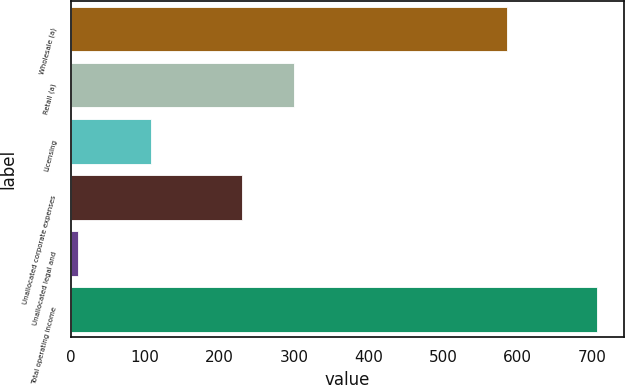<chart> <loc_0><loc_0><loc_500><loc_500><bar_chart><fcel>Wholesale (a)<fcel>Retail (a)<fcel>Licensing<fcel>Unallocated corporate expenses<fcel>Unallocated legal and<fcel>Total operating income<nl><fcel>585.3<fcel>299.59<fcel>107.4<fcel>229.9<fcel>10<fcel>706.9<nl></chart> 